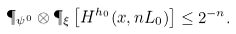<formula> <loc_0><loc_0><loc_500><loc_500>\P _ { \psi ^ { 0 } } \otimes \P _ { \xi } \left [ H ^ { h _ { 0 } } ( x , n L _ { 0 } ) \right ] \leq 2 ^ { - n } .</formula> 